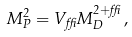Convert formula to latex. <formula><loc_0><loc_0><loc_500><loc_500>M _ { P } ^ { 2 } = V _ { \delta } M _ { D } ^ { 2 + \delta } \, ,</formula> 